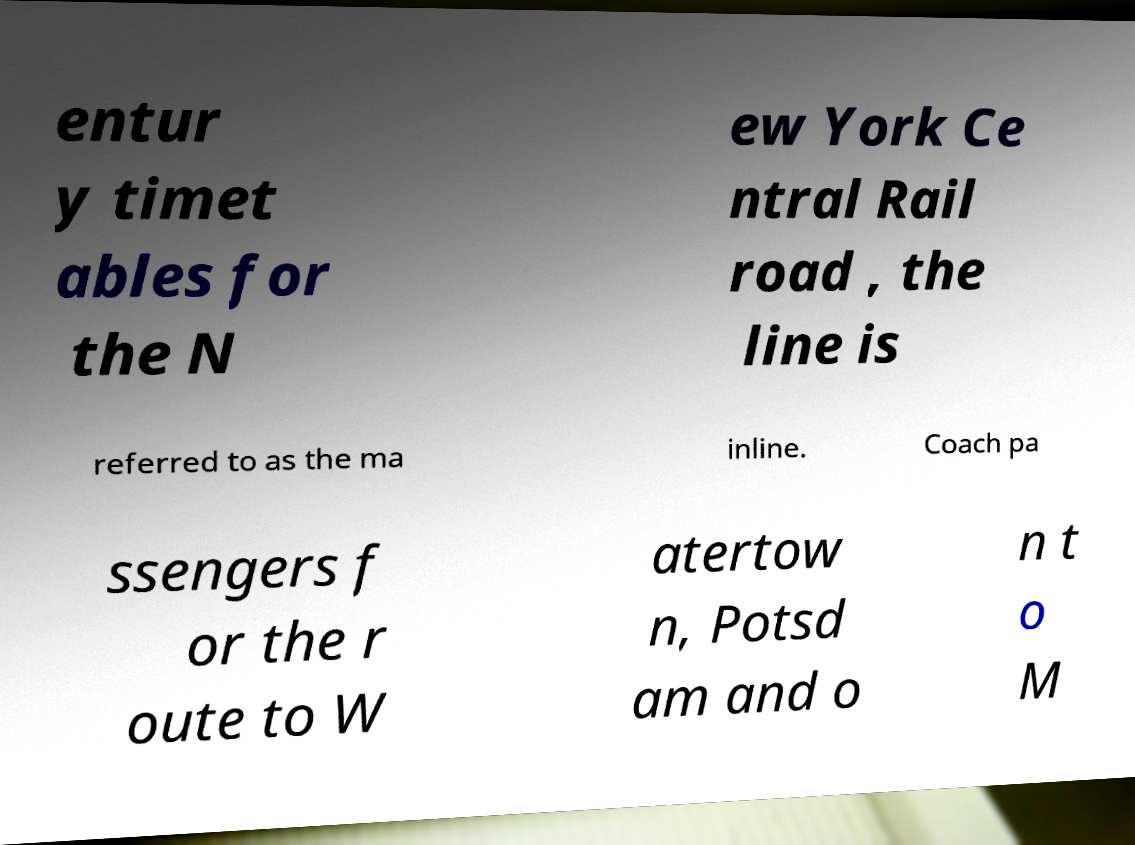For documentation purposes, I need the text within this image transcribed. Could you provide that? entur y timet ables for the N ew York Ce ntral Rail road , the line is referred to as the ma inline. Coach pa ssengers f or the r oute to W atertow n, Potsd am and o n t o M 